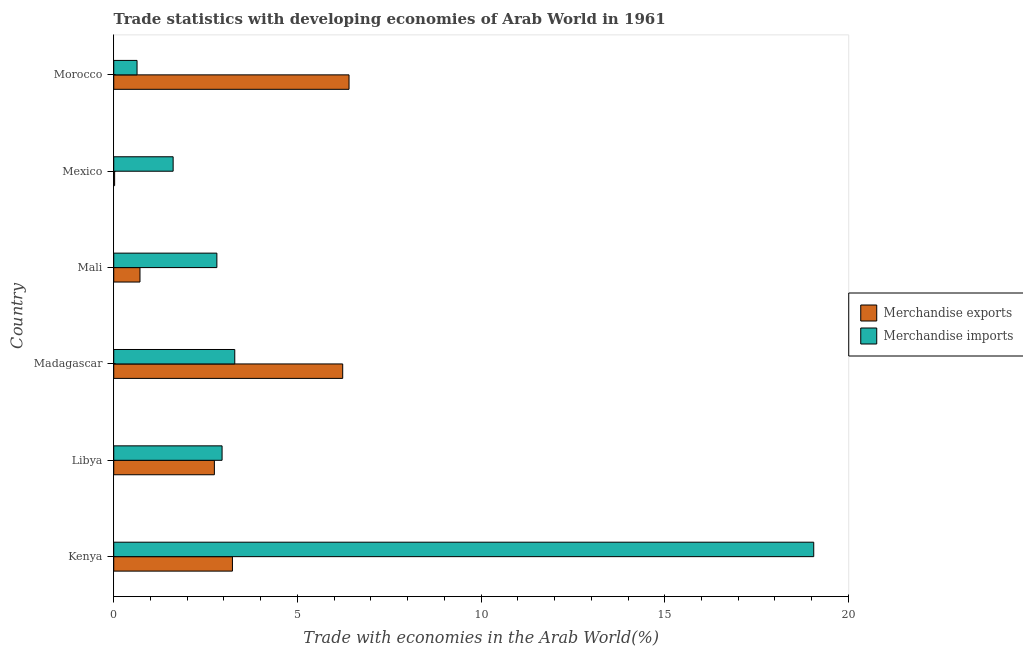How many groups of bars are there?
Offer a terse response. 6. Are the number of bars on each tick of the Y-axis equal?
Make the answer very short. Yes. How many bars are there on the 6th tick from the top?
Keep it short and to the point. 2. What is the label of the 6th group of bars from the top?
Offer a terse response. Kenya. In how many cases, is the number of bars for a given country not equal to the number of legend labels?
Provide a succinct answer. 0. What is the merchandise imports in Kenya?
Ensure brevity in your answer.  19.06. Across all countries, what is the maximum merchandise exports?
Give a very brief answer. 6.41. Across all countries, what is the minimum merchandise imports?
Your response must be concise. 0.63. In which country was the merchandise exports maximum?
Make the answer very short. Morocco. What is the total merchandise imports in the graph?
Provide a succinct answer. 30.36. What is the difference between the merchandise exports in Libya and that in Madagascar?
Provide a short and direct response. -3.49. What is the difference between the merchandise imports in Mali and the merchandise exports in Mexico?
Provide a succinct answer. 2.78. What is the average merchandise exports per country?
Offer a terse response. 3.23. What is the difference between the merchandise exports and merchandise imports in Mexico?
Keep it short and to the point. -1.59. In how many countries, is the merchandise imports greater than 17 %?
Provide a short and direct response. 1. What is the ratio of the merchandise exports in Kenya to that in Libya?
Your answer should be very brief. 1.18. Is the difference between the merchandise imports in Madagascar and Mali greater than the difference between the merchandise exports in Madagascar and Mali?
Offer a terse response. No. What is the difference between the highest and the second highest merchandise imports?
Provide a succinct answer. 15.76. What is the difference between the highest and the lowest merchandise exports?
Offer a terse response. 6.38. What does the 2nd bar from the bottom in Morocco represents?
Your answer should be very brief. Merchandise imports. What is the difference between two consecutive major ticks on the X-axis?
Make the answer very short. 5. Where does the legend appear in the graph?
Make the answer very short. Center right. How many legend labels are there?
Your answer should be very brief. 2. What is the title of the graph?
Ensure brevity in your answer.  Trade statistics with developing economies of Arab World in 1961. What is the label or title of the X-axis?
Provide a short and direct response. Trade with economies in the Arab World(%). What is the Trade with economies in the Arab World(%) in Merchandise exports in Kenya?
Your response must be concise. 3.23. What is the Trade with economies in the Arab World(%) of Merchandise imports in Kenya?
Your answer should be very brief. 19.06. What is the Trade with economies in the Arab World(%) in Merchandise exports in Libya?
Ensure brevity in your answer.  2.74. What is the Trade with economies in the Arab World(%) of Merchandise imports in Libya?
Your answer should be very brief. 2.95. What is the Trade with economies in the Arab World(%) of Merchandise exports in Madagascar?
Your answer should be compact. 6.23. What is the Trade with economies in the Arab World(%) of Merchandise imports in Madagascar?
Keep it short and to the point. 3.29. What is the Trade with economies in the Arab World(%) of Merchandise exports in Mali?
Your answer should be very brief. 0.71. What is the Trade with economies in the Arab World(%) of Merchandise imports in Mali?
Your response must be concise. 2.81. What is the Trade with economies in the Arab World(%) in Merchandise exports in Mexico?
Your response must be concise. 0.02. What is the Trade with economies in the Arab World(%) of Merchandise imports in Mexico?
Ensure brevity in your answer.  1.62. What is the Trade with economies in the Arab World(%) in Merchandise exports in Morocco?
Your response must be concise. 6.41. What is the Trade with economies in the Arab World(%) of Merchandise imports in Morocco?
Your answer should be very brief. 0.63. Across all countries, what is the maximum Trade with economies in the Arab World(%) in Merchandise exports?
Give a very brief answer. 6.41. Across all countries, what is the maximum Trade with economies in the Arab World(%) in Merchandise imports?
Ensure brevity in your answer.  19.06. Across all countries, what is the minimum Trade with economies in the Arab World(%) in Merchandise exports?
Your response must be concise. 0.02. Across all countries, what is the minimum Trade with economies in the Arab World(%) in Merchandise imports?
Your answer should be compact. 0.63. What is the total Trade with economies in the Arab World(%) in Merchandise exports in the graph?
Give a very brief answer. 19.35. What is the total Trade with economies in the Arab World(%) of Merchandise imports in the graph?
Your answer should be compact. 30.36. What is the difference between the Trade with economies in the Arab World(%) of Merchandise exports in Kenya and that in Libya?
Provide a short and direct response. 0.49. What is the difference between the Trade with economies in the Arab World(%) in Merchandise imports in Kenya and that in Libya?
Keep it short and to the point. 16.11. What is the difference between the Trade with economies in the Arab World(%) in Merchandise exports in Kenya and that in Madagascar?
Make the answer very short. -3. What is the difference between the Trade with economies in the Arab World(%) in Merchandise imports in Kenya and that in Madagascar?
Your answer should be compact. 15.76. What is the difference between the Trade with economies in the Arab World(%) of Merchandise exports in Kenya and that in Mali?
Ensure brevity in your answer.  2.52. What is the difference between the Trade with economies in the Arab World(%) of Merchandise imports in Kenya and that in Mali?
Give a very brief answer. 16.25. What is the difference between the Trade with economies in the Arab World(%) of Merchandise exports in Kenya and that in Mexico?
Offer a very short reply. 3.21. What is the difference between the Trade with economies in the Arab World(%) in Merchandise imports in Kenya and that in Mexico?
Provide a succinct answer. 17.44. What is the difference between the Trade with economies in the Arab World(%) in Merchandise exports in Kenya and that in Morocco?
Ensure brevity in your answer.  -3.17. What is the difference between the Trade with economies in the Arab World(%) of Merchandise imports in Kenya and that in Morocco?
Your response must be concise. 18.42. What is the difference between the Trade with economies in the Arab World(%) of Merchandise exports in Libya and that in Madagascar?
Your response must be concise. -3.49. What is the difference between the Trade with economies in the Arab World(%) in Merchandise imports in Libya and that in Madagascar?
Provide a succinct answer. -0.35. What is the difference between the Trade with economies in the Arab World(%) of Merchandise exports in Libya and that in Mali?
Your answer should be compact. 2.03. What is the difference between the Trade with economies in the Arab World(%) of Merchandise imports in Libya and that in Mali?
Your answer should be compact. 0.14. What is the difference between the Trade with economies in the Arab World(%) of Merchandise exports in Libya and that in Mexico?
Your answer should be compact. 2.72. What is the difference between the Trade with economies in the Arab World(%) in Merchandise imports in Libya and that in Mexico?
Offer a very short reply. 1.33. What is the difference between the Trade with economies in the Arab World(%) of Merchandise exports in Libya and that in Morocco?
Your answer should be very brief. -3.67. What is the difference between the Trade with economies in the Arab World(%) of Merchandise imports in Libya and that in Morocco?
Your answer should be compact. 2.31. What is the difference between the Trade with economies in the Arab World(%) of Merchandise exports in Madagascar and that in Mali?
Offer a very short reply. 5.52. What is the difference between the Trade with economies in the Arab World(%) in Merchandise imports in Madagascar and that in Mali?
Offer a terse response. 0.49. What is the difference between the Trade with economies in the Arab World(%) in Merchandise exports in Madagascar and that in Mexico?
Make the answer very short. 6.21. What is the difference between the Trade with economies in the Arab World(%) of Merchandise imports in Madagascar and that in Mexico?
Make the answer very short. 1.68. What is the difference between the Trade with economies in the Arab World(%) of Merchandise exports in Madagascar and that in Morocco?
Provide a succinct answer. -0.17. What is the difference between the Trade with economies in the Arab World(%) in Merchandise imports in Madagascar and that in Morocco?
Your response must be concise. 2.66. What is the difference between the Trade with economies in the Arab World(%) in Merchandise exports in Mali and that in Mexico?
Give a very brief answer. 0.69. What is the difference between the Trade with economies in the Arab World(%) in Merchandise imports in Mali and that in Mexico?
Provide a succinct answer. 1.19. What is the difference between the Trade with economies in the Arab World(%) in Merchandise exports in Mali and that in Morocco?
Provide a short and direct response. -5.69. What is the difference between the Trade with economies in the Arab World(%) in Merchandise imports in Mali and that in Morocco?
Offer a terse response. 2.17. What is the difference between the Trade with economies in the Arab World(%) in Merchandise exports in Mexico and that in Morocco?
Your response must be concise. -6.38. What is the difference between the Trade with economies in the Arab World(%) in Merchandise imports in Mexico and that in Morocco?
Offer a very short reply. 0.98. What is the difference between the Trade with economies in the Arab World(%) in Merchandise exports in Kenya and the Trade with economies in the Arab World(%) in Merchandise imports in Libya?
Provide a short and direct response. 0.28. What is the difference between the Trade with economies in the Arab World(%) of Merchandise exports in Kenya and the Trade with economies in the Arab World(%) of Merchandise imports in Madagascar?
Your answer should be compact. -0.06. What is the difference between the Trade with economies in the Arab World(%) of Merchandise exports in Kenya and the Trade with economies in the Arab World(%) of Merchandise imports in Mali?
Provide a succinct answer. 0.42. What is the difference between the Trade with economies in the Arab World(%) of Merchandise exports in Kenya and the Trade with economies in the Arab World(%) of Merchandise imports in Mexico?
Your response must be concise. 1.61. What is the difference between the Trade with economies in the Arab World(%) of Merchandise exports in Kenya and the Trade with economies in the Arab World(%) of Merchandise imports in Morocco?
Your answer should be very brief. 2.6. What is the difference between the Trade with economies in the Arab World(%) in Merchandise exports in Libya and the Trade with economies in the Arab World(%) in Merchandise imports in Madagascar?
Your answer should be very brief. -0.55. What is the difference between the Trade with economies in the Arab World(%) in Merchandise exports in Libya and the Trade with economies in the Arab World(%) in Merchandise imports in Mali?
Give a very brief answer. -0.07. What is the difference between the Trade with economies in the Arab World(%) in Merchandise exports in Libya and the Trade with economies in the Arab World(%) in Merchandise imports in Mexico?
Give a very brief answer. 1.12. What is the difference between the Trade with economies in the Arab World(%) of Merchandise exports in Libya and the Trade with economies in the Arab World(%) of Merchandise imports in Morocco?
Offer a very short reply. 2.11. What is the difference between the Trade with economies in the Arab World(%) of Merchandise exports in Madagascar and the Trade with economies in the Arab World(%) of Merchandise imports in Mali?
Your answer should be compact. 3.43. What is the difference between the Trade with economies in the Arab World(%) in Merchandise exports in Madagascar and the Trade with economies in the Arab World(%) in Merchandise imports in Mexico?
Make the answer very short. 4.62. What is the difference between the Trade with economies in the Arab World(%) in Merchandise exports in Madagascar and the Trade with economies in the Arab World(%) in Merchandise imports in Morocco?
Provide a short and direct response. 5.6. What is the difference between the Trade with economies in the Arab World(%) of Merchandise exports in Mali and the Trade with economies in the Arab World(%) of Merchandise imports in Mexico?
Your answer should be very brief. -0.9. What is the difference between the Trade with economies in the Arab World(%) in Merchandise exports in Mali and the Trade with economies in the Arab World(%) in Merchandise imports in Morocco?
Give a very brief answer. 0.08. What is the difference between the Trade with economies in the Arab World(%) of Merchandise exports in Mexico and the Trade with economies in the Arab World(%) of Merchandise imports in Morocco?
Your answer should be very brief. -0.61. What is the average Trade with economies in the Arab World(%) in Merchandise exports per country?
Offer a very short reply. 3.22. What is the average Trade with economies in the Arab World(%) of Merchandise imports per country?
Your response must be concise. 5.06. What is the difference between the Trade with economies in the Arab World(%) in Merchandise exports and Trade with economies in the Arab World(%) in Merchandise imports in Kenya?
Provide a short and direct response. -15.82. What is the difference between the Trade with economies in the Arab World(%) in Merchandise exports and Trade with economies in the Arab World(%) in Merchandise imports in Libya?
Provide a short and direct response. -0.21. What is the difference between the Trade with economies in the Arab World(%) in Merchandise exports and Trade with economies in the Arab World(%) in Merchandise imports in Madagascar?
Ensure brevity in your answer.  2.94. What is the difference between the Trade with economies in the Arab World(%) of Merchandise exports and Trade with economies in the Arab World(%) of Merchandise imports in Mali?
Provide a succinct answer. -2.09. What is the difference between the Trade with economies in the Arab World(%) of Merchandise exports and Trade with economies in the Arab World(%) of Merchandise imports in Mexico?
Give a very brief answer. -1.59. What is the difference between the Trade with economies in the Arab World(%) of Merchandise exports and Trade with economies in the Arab World(%) of Merchandise imports in Morocco?
Offer a very short reply. 5.77. What is the ratio of the Trade with economies in the Arab World(%) in Merchandise exports in Kenya to that in Libya?
Offer a terse response. 1.18. What is the ratio of the Trade with economies in the Arab World(%) of Merchandise imports in Kenya to that in Libya?
Ensure brevity in your answer.  6.46. What is the ratio of the Trade with economies in the Arab World(%) in Merchandise exports in Kenya to that in Madagascar?
Offer a terse response. 0.52. What is the ratio of the Trade with economies in the Arab World(%) of Merchandise imports in Kenya to that in Madagascar?
Your response must be concise. 5.78. What is the ratio of the Trade with economies in the Arab World(%) of Merchandise exports in Kenya to that in Mali?
Provide a succinct answer. 4.52. What is the ratio of the Trade with economies in the Arab World(%) of Merchandise imports in Kenya to that in Mali?
Ensure brevity in your answer.  6.79. What is the ratio of the Trade with economies in the Arab World(%) in Merchandise exports in Kenya to that in Mexico?
Your answer should be very brief. 133.39. What is the ratio of the Trade with economies in the Arab World(%) in Merchandise imports in Kenya to that in Mexico?
Your answer should be very brief. 11.79. What is the ratio of the Trade with economies in the Arab World(%) in Merchandise exports in Kenya to that in Morocco?
Make the answer very short. 0.5. What is the ratio of the Trade with economies in the Arab World(%) in Merchandise imports in Kenya to that in Morocco?
Your response must be concise. 30.04. What is the ratio of the Trade with economies in the Arab World(%) in Merchandise exports in Libya to that in Madagascar?
Make the answer very short. 0.44. What is the ratio of the Trade with economies in the Arab World(%) in Merchandise imports in Libya to that in Madagascar?
Provide a short and direct response. 0.9. What is the ratio of the Trade with economies in the Arab World(%) in Merchandise exports in Libya to that in Mali?
Keep it short and to the point. 3.84. What is the ratio of the Trade with economies in the Arab World(%) in Merchandise imports in Libya to that in Mali?
Give a very brief answer. 1.05. What is the ratio of the Trade with economies in the Arab World(%) in Merchandise exports in Libya to that in Mexico?
Make the answer very short. 113.1. What is the ratio of the Trade with economies in the Arab World(%) of Merchandise imports in Libya to that in Mexico?
Provide a succinct answer. 1.82. What is the ratio of the Trade with economies in the Arab World(%) in Merchandise exports in Libya to that in Morocco?
Provide a succinct answer. 0.43. What is the ratio of the Trade with economies in the Arab World(%) of Merchandise imports in Libya to that in Morocco?
Your answer should be very brief. 4.65. What is the ratio of the Trade with economies in the Arab World(%) in Merchandise exports in Madagascar to that in Mali?
Make the answer very short. 8.73. What is the ratio of the Trade with economies in the Arab World(%) in Merchandise imports in Madagascar to that in Mali?
Your response must be concise. 1.17. What is the ratio of the Trade with economies in the Arab World(%) of Merchandise exports in Madagascar to that in Mexico?
Give a very brief answer. 257.3. What is the ratio of the Trade with economies in the Arab World(%) of Merchandise imports in Madagascar to that in Mexico?
Offer a terse response. 2.04. What is the ratio of the Trade with economies in the Arab World(%) in Merchandise exports in Madagascar to that in Morocco?
Your answer should be compact. 0.97. What is the ratio of the Trade with economies in the Arab World(%) in Merchandise imports in Madagascar to that in Morocco?
Keep it short and to the point. 5.19. What is the ratio of the Trade with economies in the Arab World(%) of Merchandise exports in Mali to that in Mexico?
Ensure brevity in your answer.  29.49. What is the ratio of the Trade with economies in the Arab World(%) of Merchandise imports in Mali to that in Mexico?
Your response must be concise. 1.74. What is the ratio of the Trade with economies in the Arab World(%) of Merchandise exports in Mali to that in Morocco?
Make the answer very short. 0.11. What is the ratio of the Trade with economies in the Arab World(%) in Merchandise imports in Mali to that in Morocco?
Give a very brief answer. 4.43. What is the ratio of the Trade with economies in the Arab World(%) of Merchandise exports in Mexico to that in Morocco?
Make the answer very short. 0. What is the ratio of the Trade with economies in the Arab World(%) of Merchandise imports in Mexico to that in Morocco?
Keep it short and to the point. 2.55. What is the difference between the highest and the second highest Trade with economies in the Arab World(%) in Merchandise exports?
Keep it short and to the point. 0.17. What is the difference between the highest and the second highest Trade with economies in the Arab World(%) of Merchandise imports?
Your answer should be very brief. 15.76. What is the difference between the highest and the lowest Trade with economies in the Arab World(%) of Merchandise exports?
Provide a succinct answer. 6.38. What is the difference between the highest and the lowest Trade with economies in the Arab World(%) of Merchandise imports?
Your answer should be compact. 18.42. 